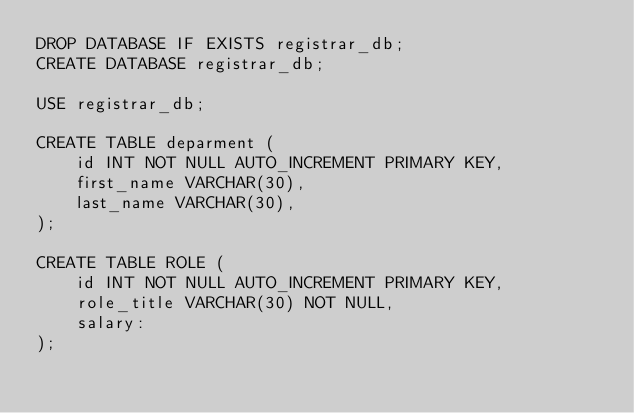Convert code to text. <code><loc_0><loc_0><loc_500><loc_500><_SQL_>DROP DATABASE IF EXISTS registrar_db;
CREATE DATABASE registrar_db;

USE registrar_db;

CREATE TABLE deparment (
    id INT NOT NULL AUTO_INCREMENT PRIMARY KEY,
    first_name VARCHAR(30),
    last_name VARCHAR(30),
);

CREATE TABLE ROLE (
    id INT NOT NULL AUTO_INCREMENT PRIMARY KEY,
    role_title VARCHAR(30) NOT NULL,
    salary: 
);</code> 